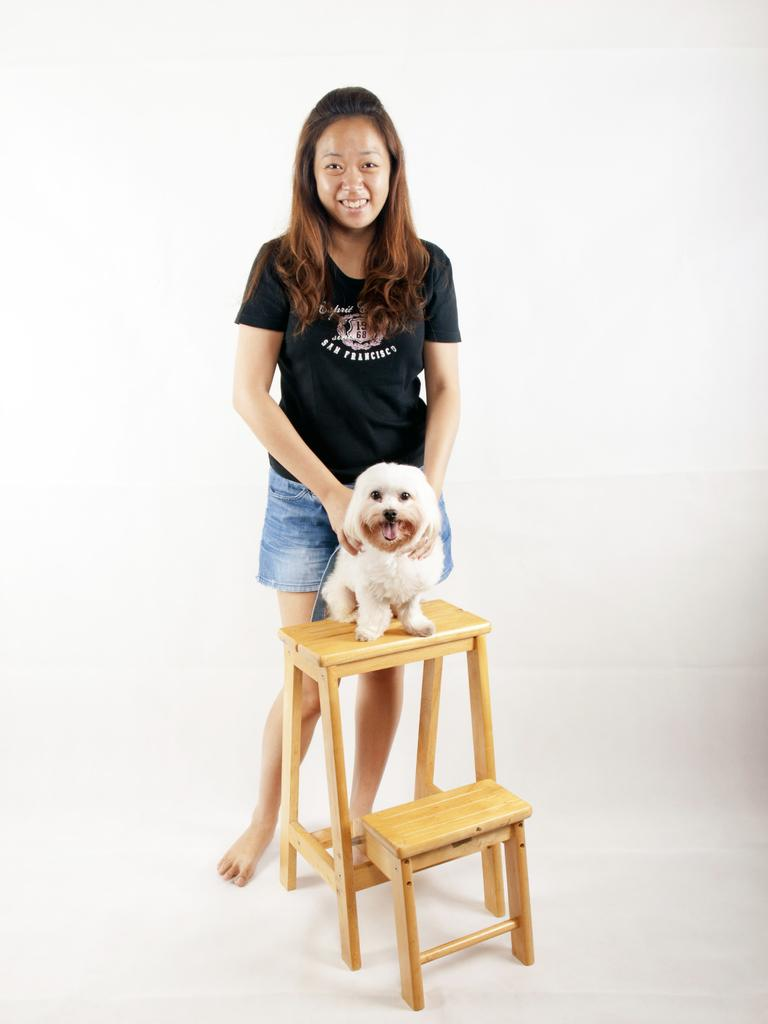Who is the main subject in the image? There is a woman in the image. What is the woman wearing? The woman is wearing a black t-shirt. What object is near the woman in the image? The woman is standing near a stool. What is the woman doing with her hands? The woman is holding a puppy with her hands. What is the woman's facial expression? The woman is smiling. Can you identify any other living creature in the image? Yes, there is a puppy visible in the image. What is the family structure of the woman and the puppy in the image? The image does not provide information about the family structure of the woman and the puppy. What form does the puppy have in the image? The image does not describe the form or shape of the puppy, but it is visible as a living creature being held by the woman. 